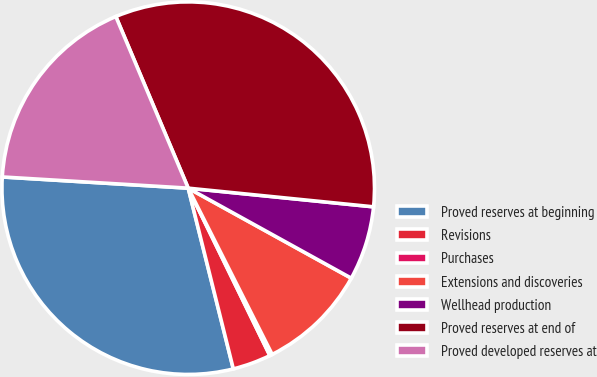Convert chart. <chart><loc_0><loc_0><loc_500><loc_500><pie_chart><fcel>Proved reserves at beginning<fcel>Revisions<fcel>Purchases<fcel>Extensions and discoveries<fcel>Wellhead production<fcel>Proved reserves at end of<fcel>Proved developed reserves at<nl><fcel>29.85%<fcel>3.33%<fcel>0.22%<fcel>9.53%<fcel>6.43%<fcel>32.95%<fcel>17.69%<nl></chart> 